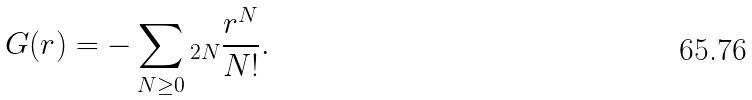Convert formula to latex. <formula><loc_0><loc_0><loc_500><loc_500>\ G ( r ) = - \sum _ { N \geq 0 } \L _ { 2 N } \frac { r ^ { N } } { N ! } .</formula> 